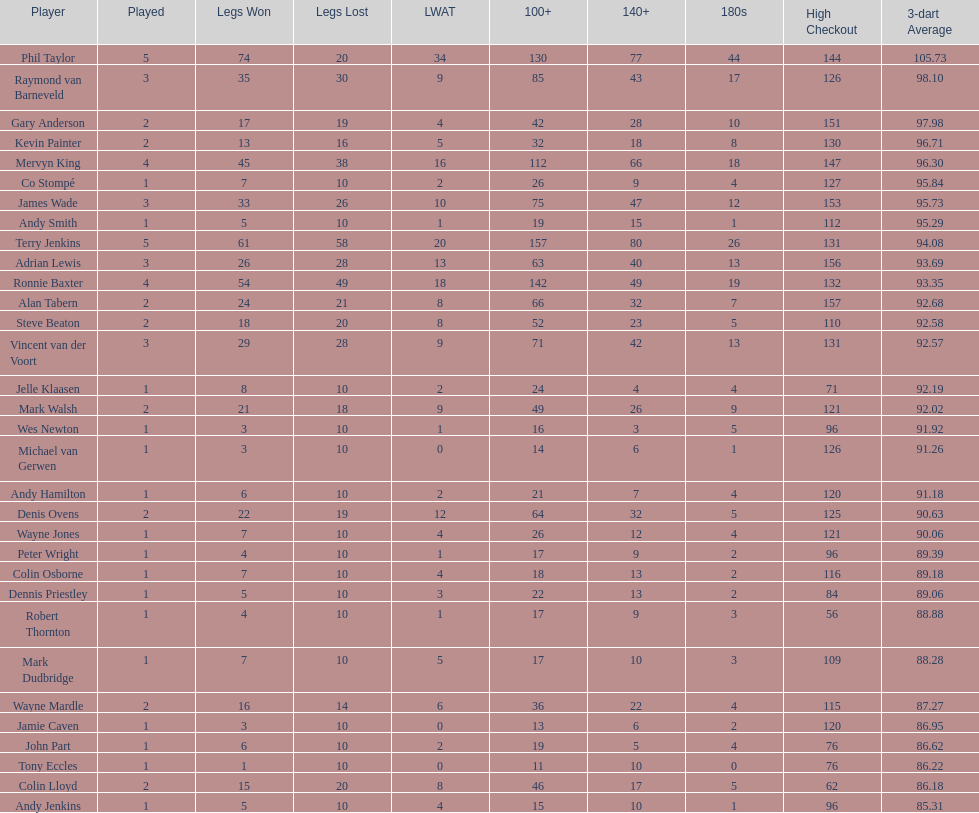How many players in the 2009 world matchplay won at least 30 legs? 6. 